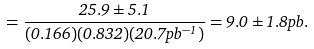<formula> <loc_0><loc_0><loc_500><loc_500>= \frac { 2 5 . 9 \pm 5 . 1 } { ( 0 . 1 6 6 ) ( 0 . 8 3 2 ) ( 2 0 . 7 p b ^ { - 1 } ) } = 9 . 0 \pm 1 . 8 p b .</formula> 